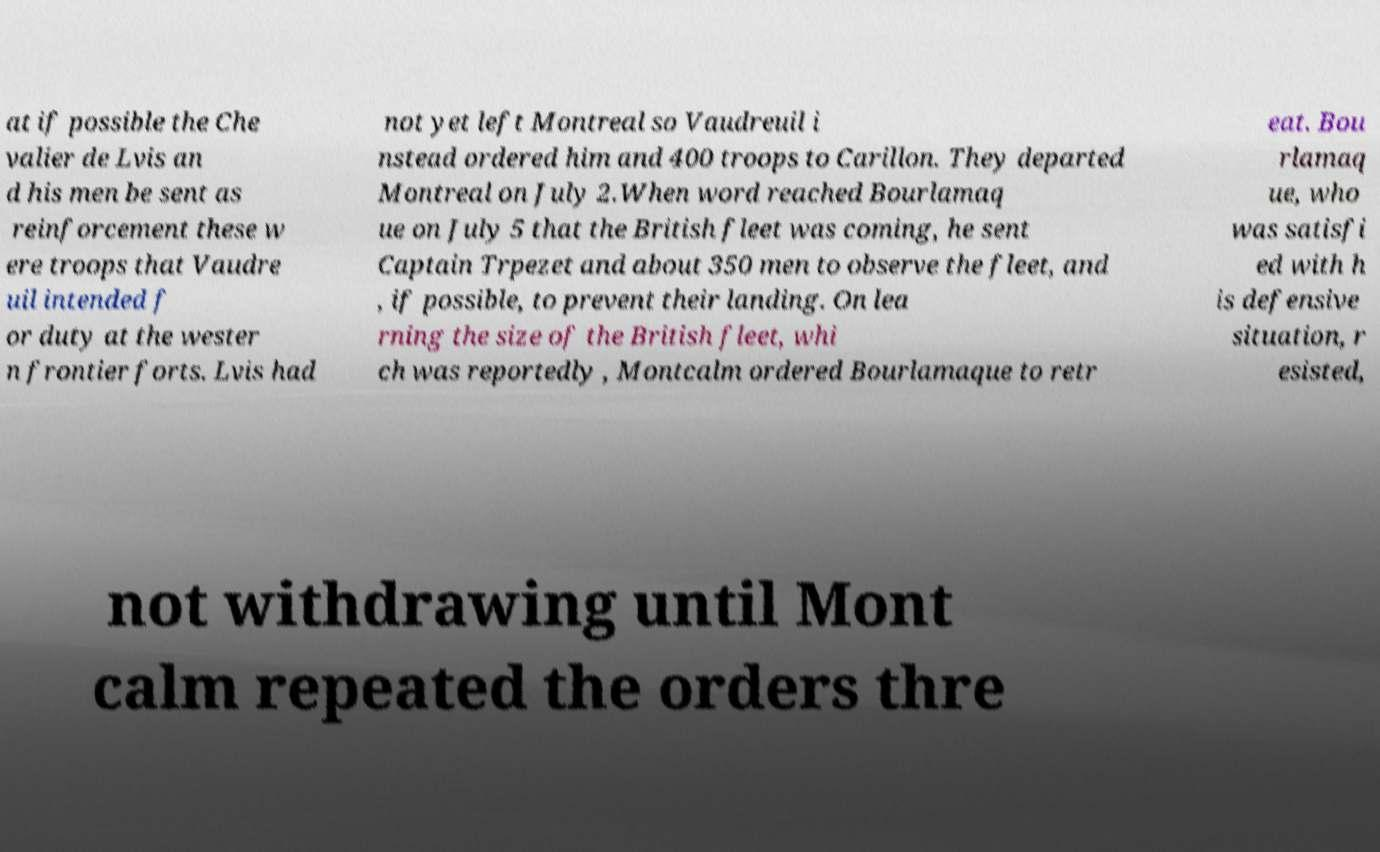Can you accurately transcribe the text from the provided image for me? at if possible the Che valier de Lvis an d his men be sent as reinforcement these w ere troops that Vaudre uil intended f or duty at the wester n frontier forts. Lvis had not yet left Montreal so Vaudreuil i nstead ordered him and 400 troops to Carillon. They departed Montreal on July 2.When word reached Bourlamaq ue on July 5 that the British fleet was coming, he sent Captain Trpezet and about 350 men to observe the fleet, and , if possible, to prevent their landing. On lea rning the size of the British fleet, whi ch was reportedly , Montcalm ordered Bourlamaque to retr eat. Bou rlamaq ue, who was satisfi ed with h is defensive situation, r esisted, not withdrawing until Mont calm repeated the orders thre 